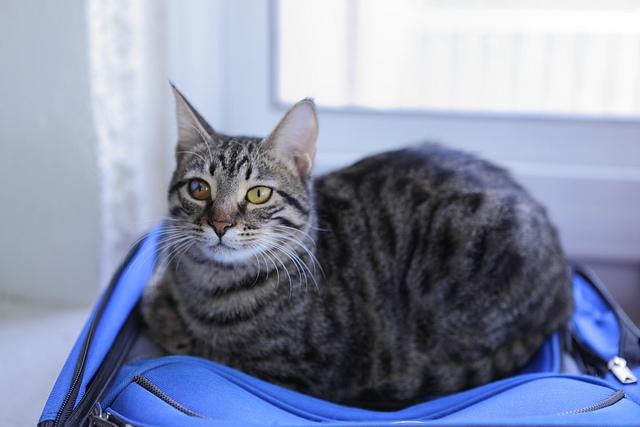Is there a zipper in the picture?
Write a very short answer. Yes. What color are cats eyes?
Quick response, please. Yellow. Is the pet in its bed?
Give a very brief answer. No. What color are the cat's eyes?
Write a very short answer. Yellow. Should the cat be there?
Concise answer only. No. 